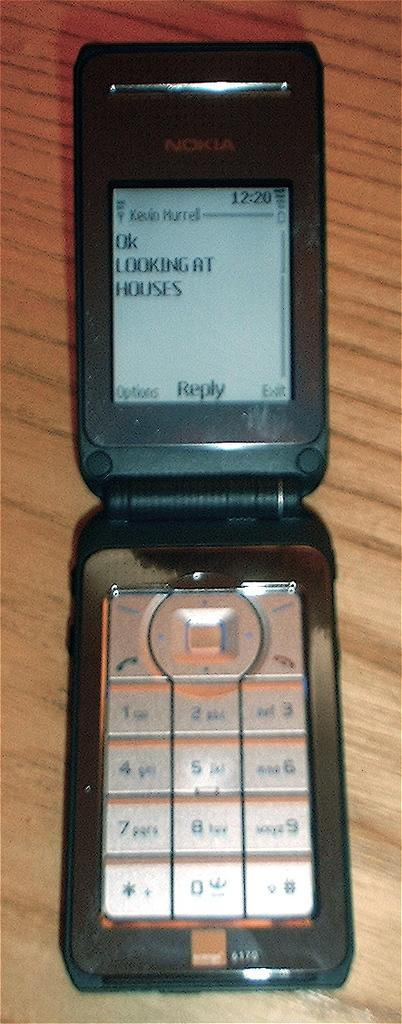<image>
Describe the image concisely. A black flip phone with a messaged displayed on the screen that says "Ok looking at houses". 